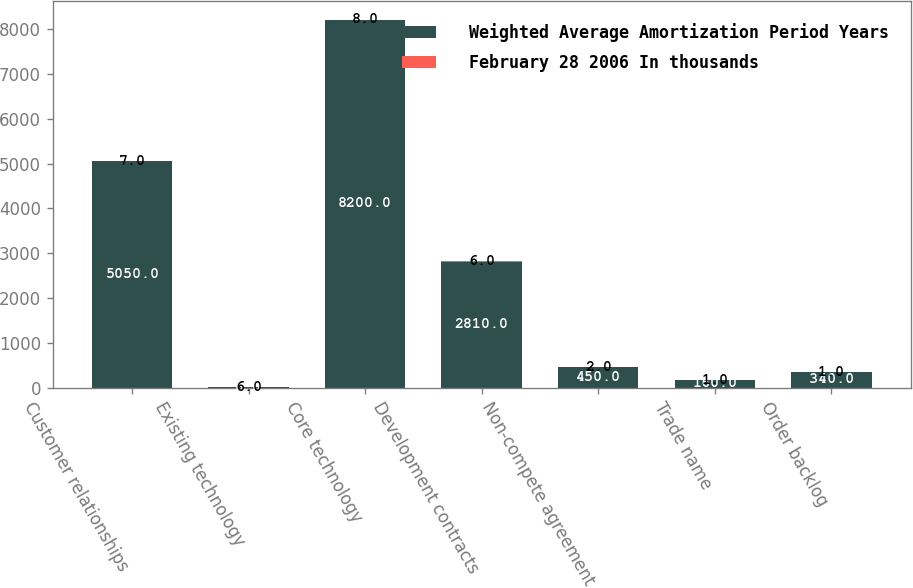<chart> <loc_0><loc_0><loc_500><loc_500><stacked_bar_chart><ecel><fcel>Customer relationships<fcel>Existing technology<fcel>Core technology<fcel>Development contracts<fcel>Non-compete agreement<fcel>Trade name<fcel>Order backlog<nl><fcel>Weighted Average Amortization Period Years<fcel>5050<fcel>8<fcel>8200<fcel>2810<fcel>450<fcel>160<fcel>340<nl><fcel>February 28 2006 In thousands<fcel>7<fcel>6<fcel>8<fcel>6<fcel>2<fcel>1<fcel>1<nl></chart> 